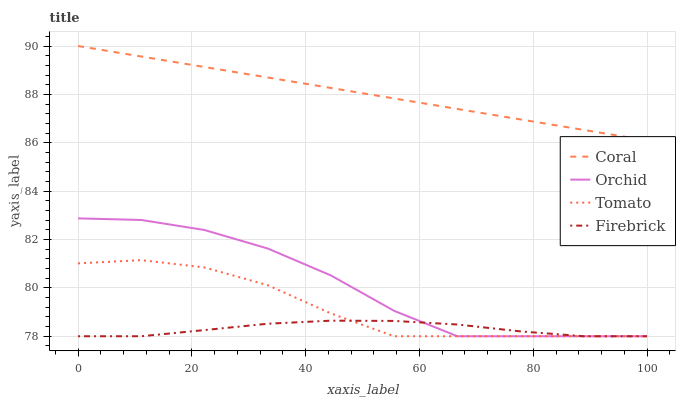Does Firebrick have the minimum area under the curve?
Answer yes or no. Yes. Does Coral have the maximum area under the curve?
Answer yes or no. Yes. Does Coral have the minimum area under the curve?
Answer yes or no. No. Does Firebrick have the maximum area under the curve?
Answer yes or no. No. Is Coral the smoothest?
Answer yes or no. Yes. Is Orchid the roughest?
Answer yes or no. Yes. Is Firebrick the smoothest?
Answer yes or no. No. Is Firebrick the roughest?
Answer yes or no. No. Does Tomato have the lowest value?
Answer yes or no. Yes. Does Coral have the lowest value?
Answer yes or no. No. Does Coral have the highest value?
Answer yes or no. Yes. Does Firebrick have the highest value?
Answer yes or no. No. Is Orchid less than Coral?
Answer yes or no. Yes. Is Coral greater than Orchid?
Answer yes or no. Yes. Does Tomato intersect Firebrick?
Answer yes or no. Yes. Is Tomato less than Firebrick?
Answer yes or no. No. Is Tomato greater than Firebrick?
Answer yes or no. No. Does Orchid intersect Coral?
Answer yes or no. No. 